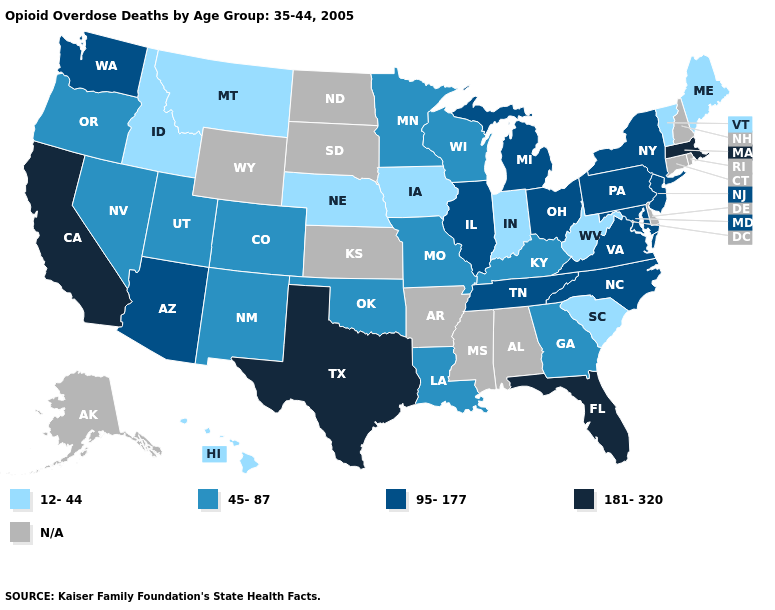Name the states that have a value in the range 45-87?
Give a very brief answer. Colorado, Georgia, Kentucky, Louisiana, Minnesota, Missouri, Nevada, New Mexico, Oklahoma, Oregon, Utah, Wisconsin. What is the value of Louisiana?
Answer briefly. 45-87. Name the states that have a value in the range N/A?
Answer briefly. Alabama, Alaska, Arkansas, Connecticut, Delaware, Kansas, Mississippi, New Hampshire, North Dakota, Rhode Island, South Dakota, Wyoming. Name the states that have a value in the range 45-87?
Concise answer only. Colorado, Georgia, Kentucky, Louisiana, Minnesota, Missouri, Nevada, New Mexico, Oklahoma, Oregon, Utah, Wisconsin. What is the value of Kentucky?
Answer briefly. 45-87. What is the value of Nebraska?
Concise answer only. 12-44. What is the lowest value in states that border New Jersey?
Quick response, please. 95-177. What is the value of Delaware?
Keep it brief. N/A. Name the states that have a value in the range 12-44?
Quick response, please. Hawaii, Idaho, Indiana, Iowa, Maine, Montana, Nebraska, South Carolina, Vermont, West Virginia. Name the states that have a value in the range 95-177?
Short answer required. Arizona, Illinois, Maryland, Michigan, New Jersey, New York, North Carolina, Ohio, Pennsylvania, Tennessee, Virginia, Washington. What is the lowest value in the West?
Answer briefly. 12-44. Name the states that have a value in the range N/A?
Answer briefly. Alabama, Alaska, Arkansas, Connecticut, Delaware, Kansas, Mississippi, New Hampshire, North Dakota, Rhode Island, South Dakota, Wyoming. How many symbols are there in the legend?
Concise answer only. 5. 